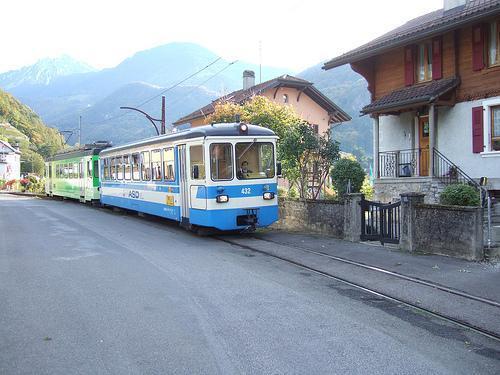How many trains are there?
Give a very brief answer. 1. 